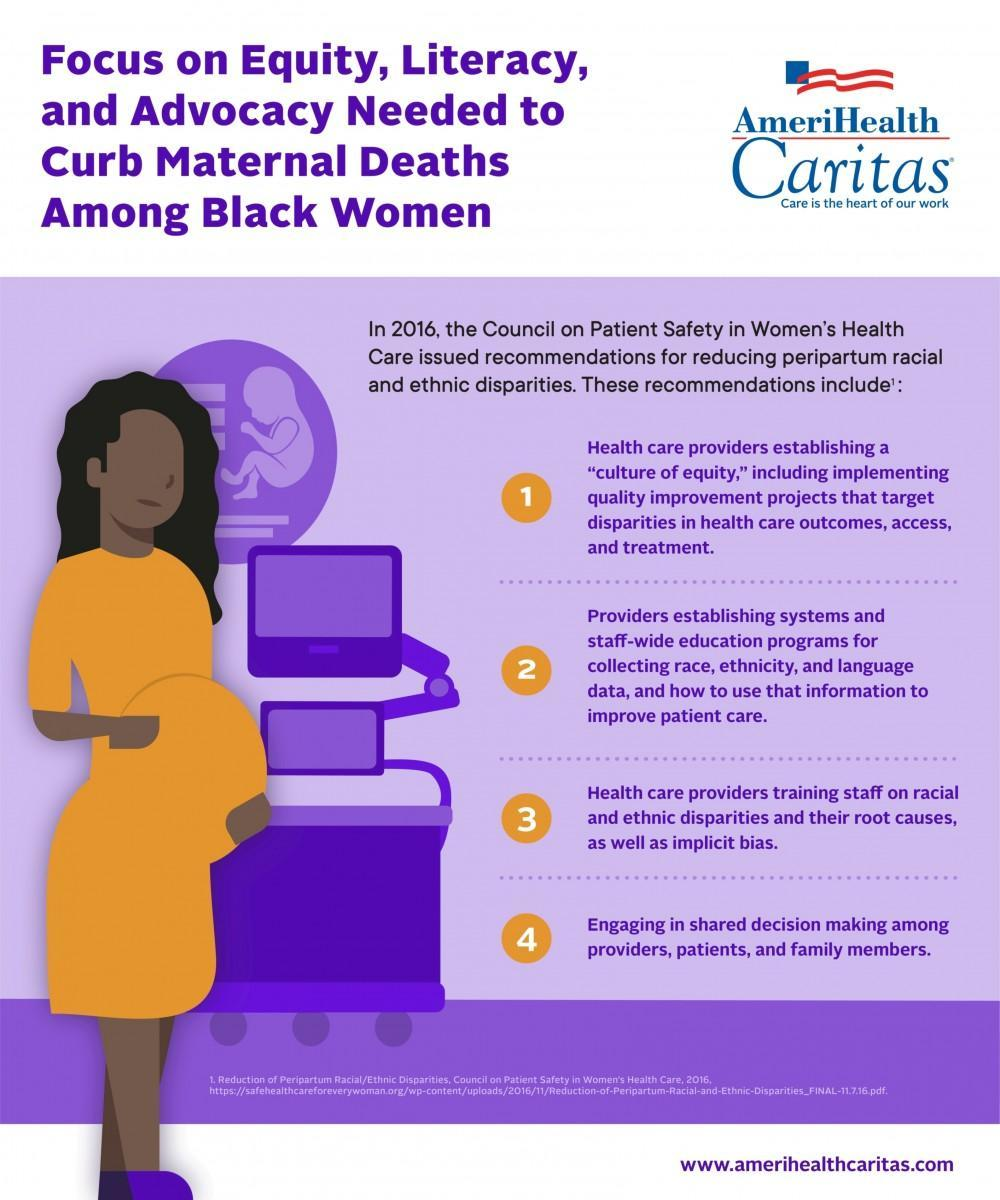How many recommendations were given to reduce peripartum racial and ethnic disparities ?
Answer the question with a short phrase. 4 